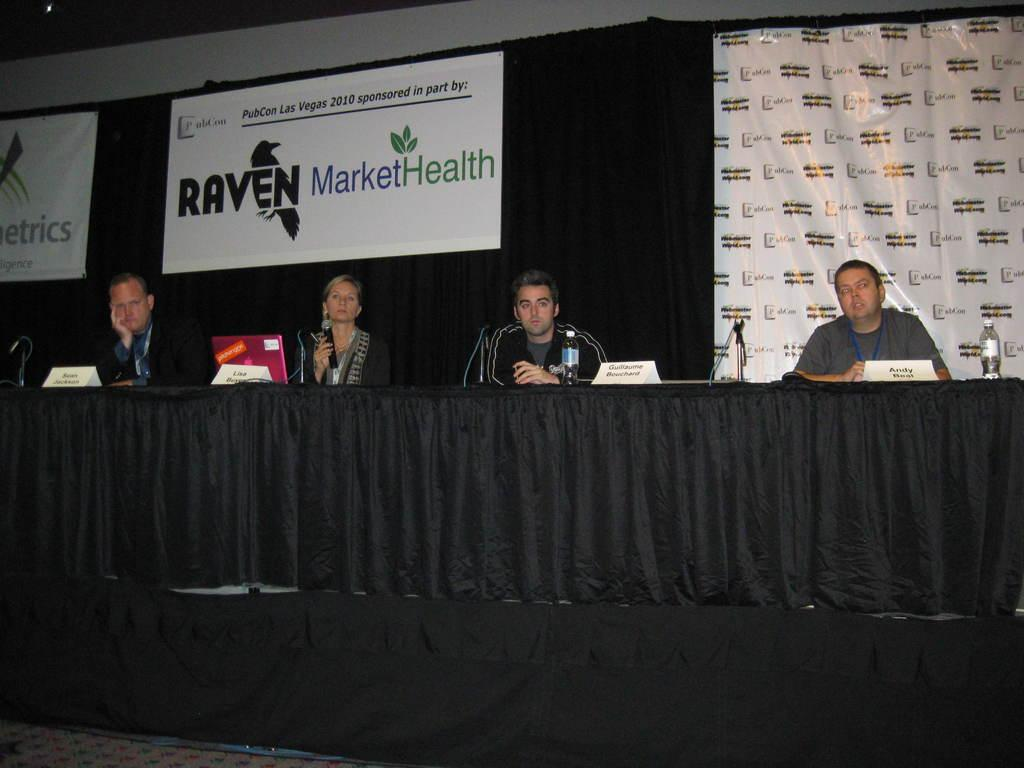How many people are present in the image? There are four people in the image: three men and one woman. What is the woman holding in the image? The woman is holding a mic with her hand. What type of objects can be seen in the image? There are bottles, name boards, cloth, and other objects in the image. What is visible in the background of the image? There are banners in the background of the image. What type of crack is visible on the jeans worn by one of the men in the image? There are no jeans present in the image, and therefore no cracks can be observed on them. Is there a crown visible on the head of any person in the image? No, there is no crown visible on the head of any person in the image. 